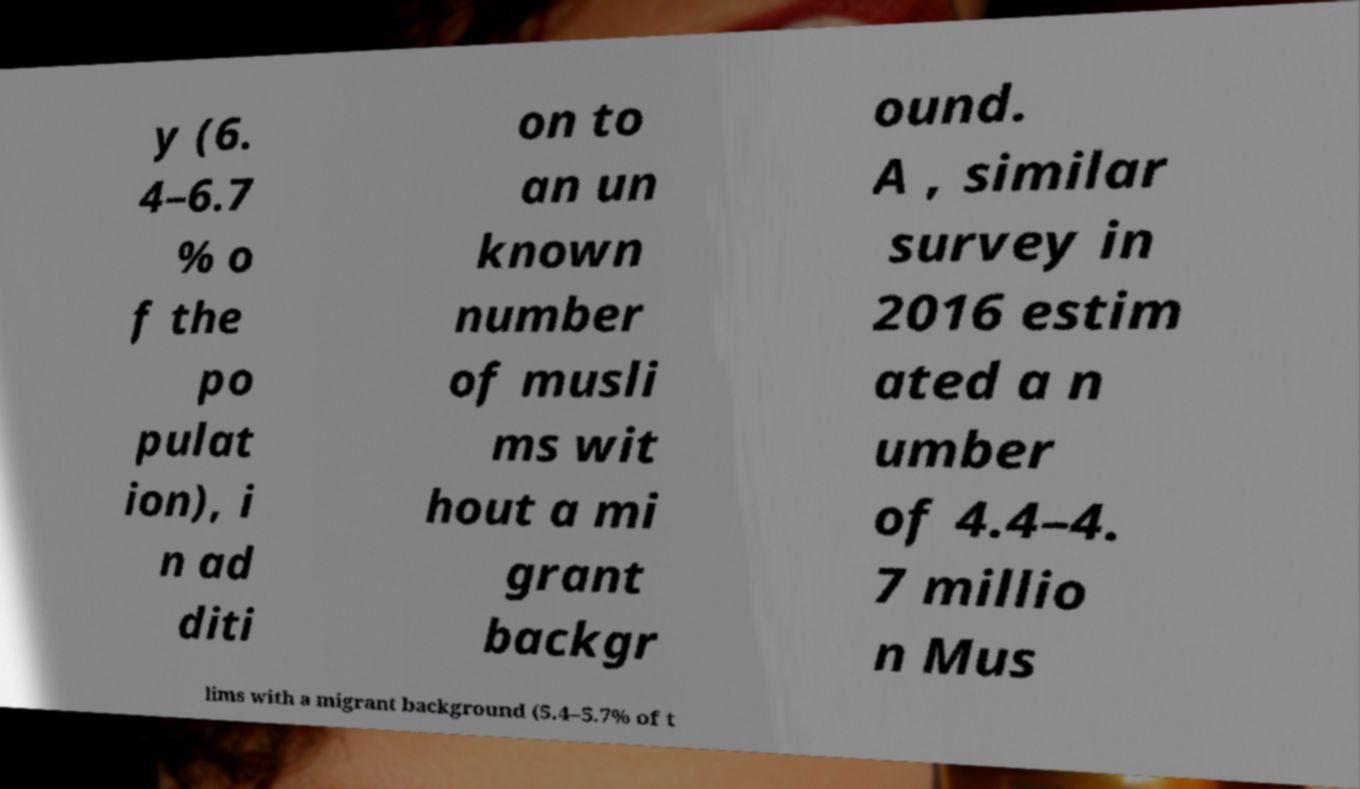For documentation purposes, I need the text within this image transcribed. Could you provide that? y (6. 4–6.7 % o f the po pulat ion), i n ad diti on to an un known number of musli ms wit hout a mi grant backgr ound. A , similar survey in 2016 estim ated a n umber of 4.4–4. 7 millio n Mus lims with a migrant background (5.4–5.7% of t 